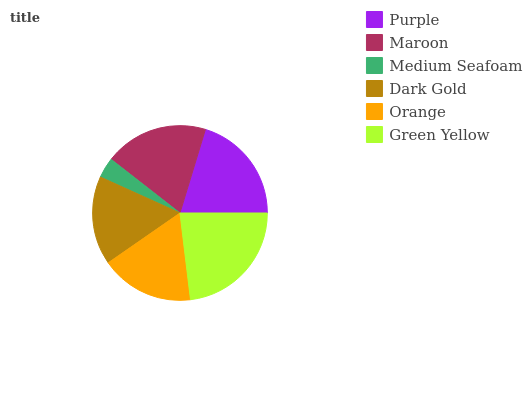Is Medium Seafoam the minimum?
Answer yes or no. Yes. Is Green Yellow the maximum?
Answer yes or no. Yes. Is Maroon the minimum?
Answer yes or no. No. Is Maroon the maximum?
Answer yes or no. No. Is Purple greater than Maroon?
Answer yes or no. Yes. Is Maroon less than Purple?
Answer yes or no. Yes. Is Maroon greater than Purple?
Answer yes or no. No. Is Purple less than Maroon?
Answer yes or no. No. Is Maroon the high median?
Answer yes or no. Yes. Is Orange the low median?
Answer yes or no. Yes. Is Dark Gold the high median?
Answer yes or no. No. Is Medium Seafoam the low median?
Answer yes or no. No. 